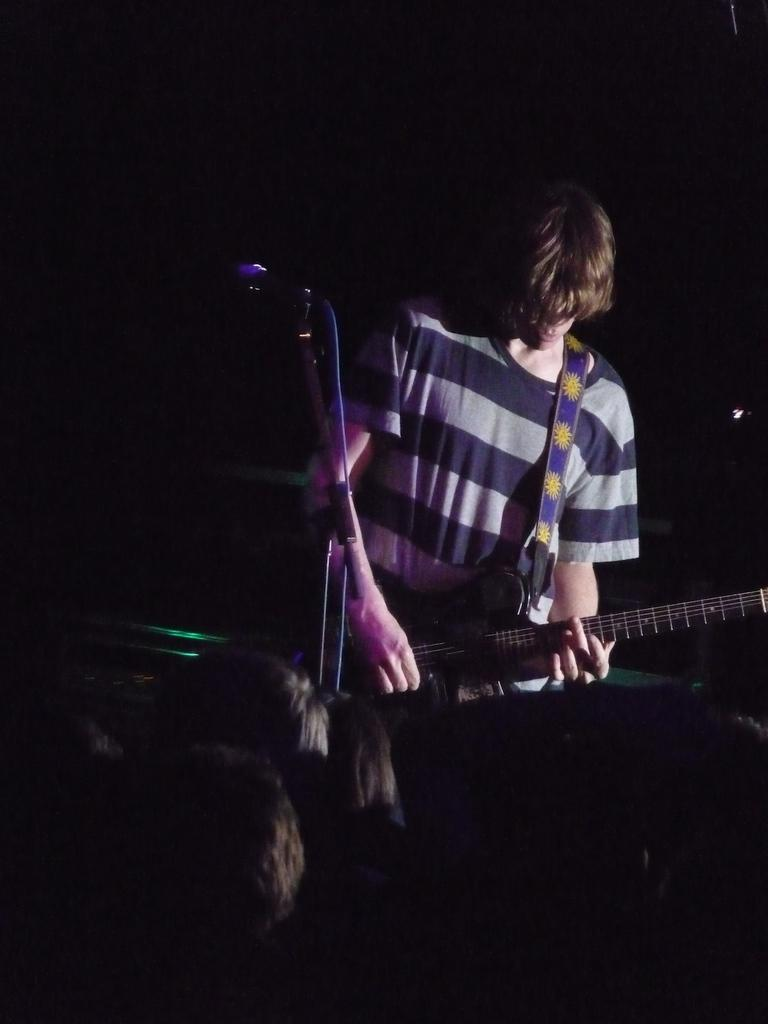What is the man in the image doing? The man is playing a guitar in the image. What object is present for amplifying the man's voice? There is a microphone with a holder in the image. Who is present to listen to the man's performance? There are people who can be considered as an audience in the image. What type of tomatoes can be seen growing in the image? There are no tomatoes present in the image; it features a man playing a guitar, a microphone with a holder, and an audience. 